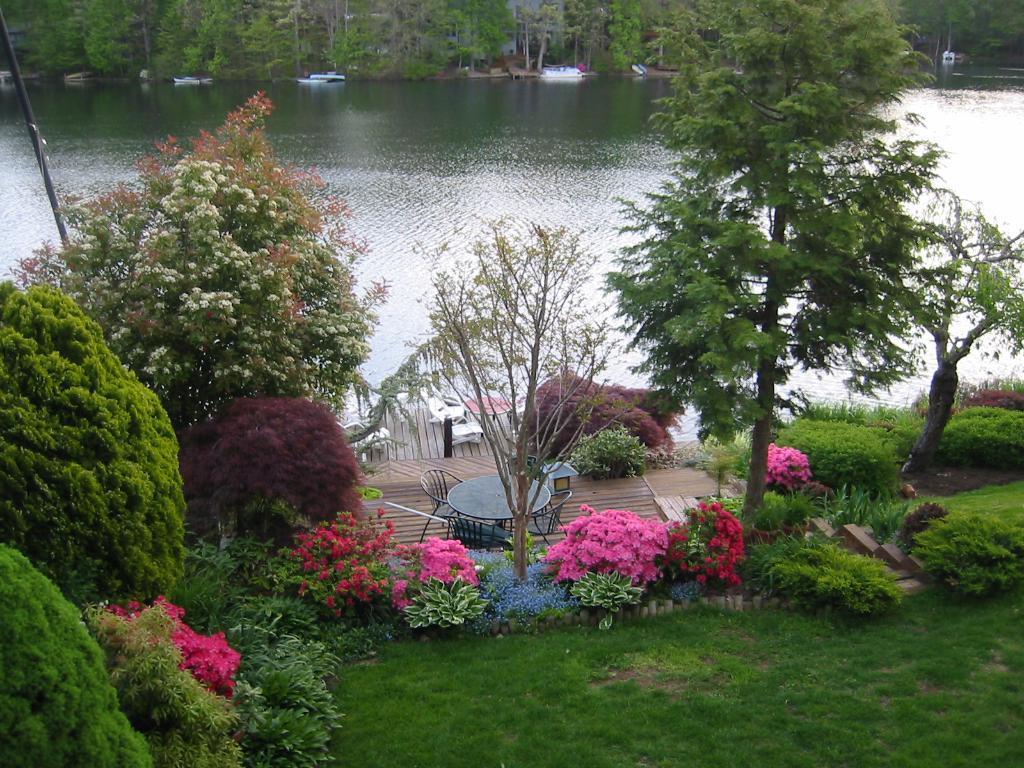How would you summarize this image in a sentence or two? In this image we can see table, chairs, grass, wooden flooring, plants, trees, river and boats. 